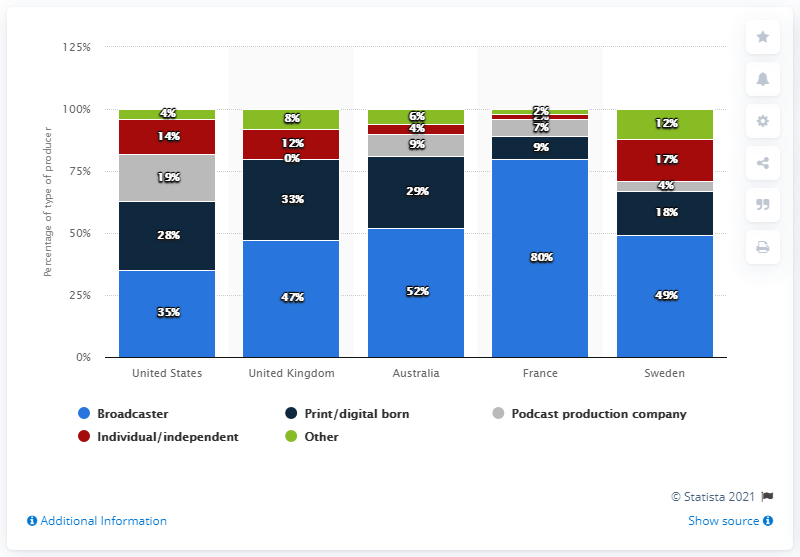List a handful of essential elements in this visual. French broadcasters were responsible for 80% of podcast production in a certain country. The highest-rated news podcast in France is produced by a well-known broadcaster. The United Kingdom has the least value among the given options. 